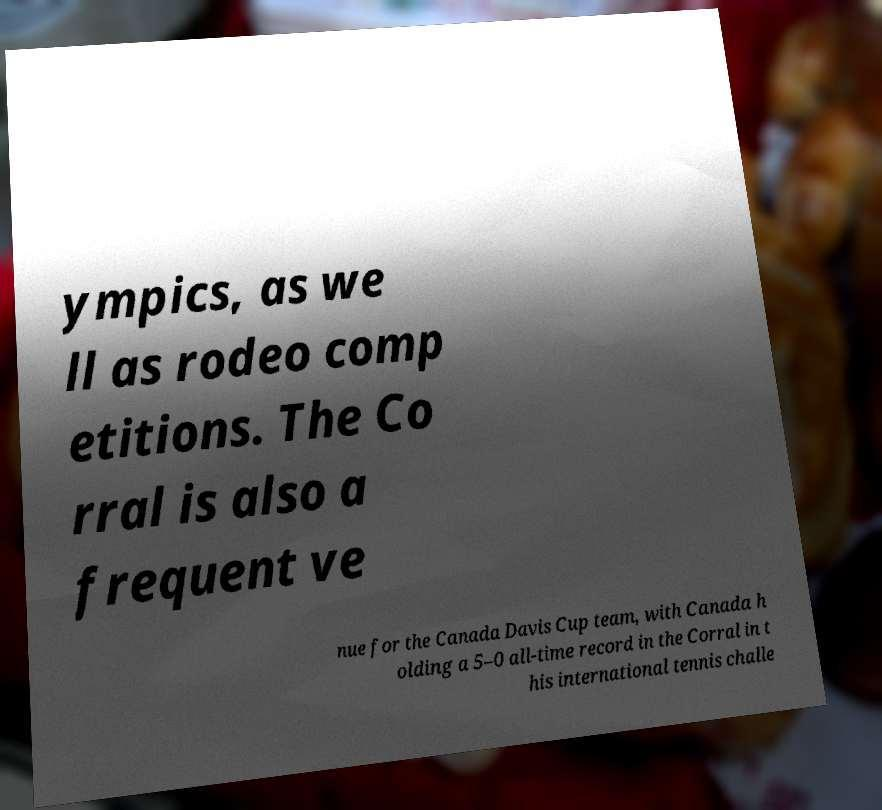Please identify and transcribe the text found in this image. ympics, as we ll as rodeo comp etitions. The Co rral is also a frequent ve nue for the Canada Davis Cup team, with Canada h olding a 5–0 all-time record in the Corral in t his international tennis challe 